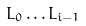<formula> <loc_0><loc_0><loc_500><loc_500>L _ { 0 } \dots L _ { i - 1 }</formula> 